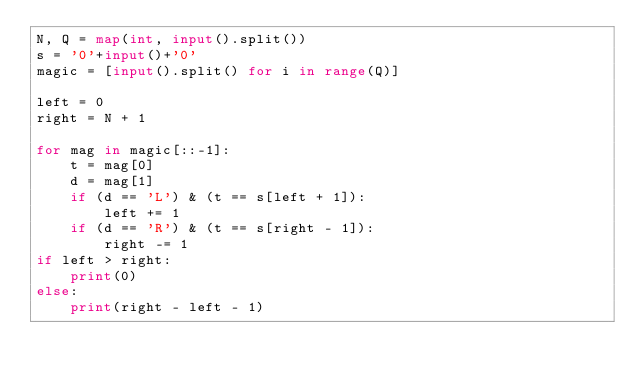Convert code to text. <code><loc_0><loc_0><loc_500><loc_500><_Python_>N, Q = map(int, input().split())
s = '0'+input()+'0'
magic = [input().split() for i in range(Q)]

left = 0
right = N + 1

for mag in magic[::-1]:
    t = mag[0]
    d = mag[1]
    if (d == 'L') & (t == s[left + 1]):
        left += 1
    if (d == 'R') & (t == s[right - 1]):
        right -= 1
if left > right:
    print(0)
else:
    print(right - left - 1)</code> 